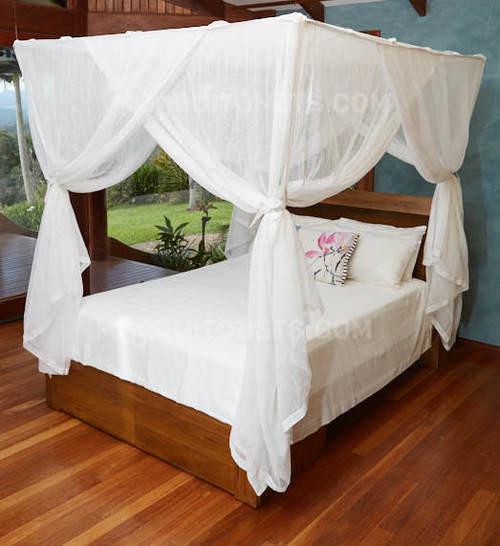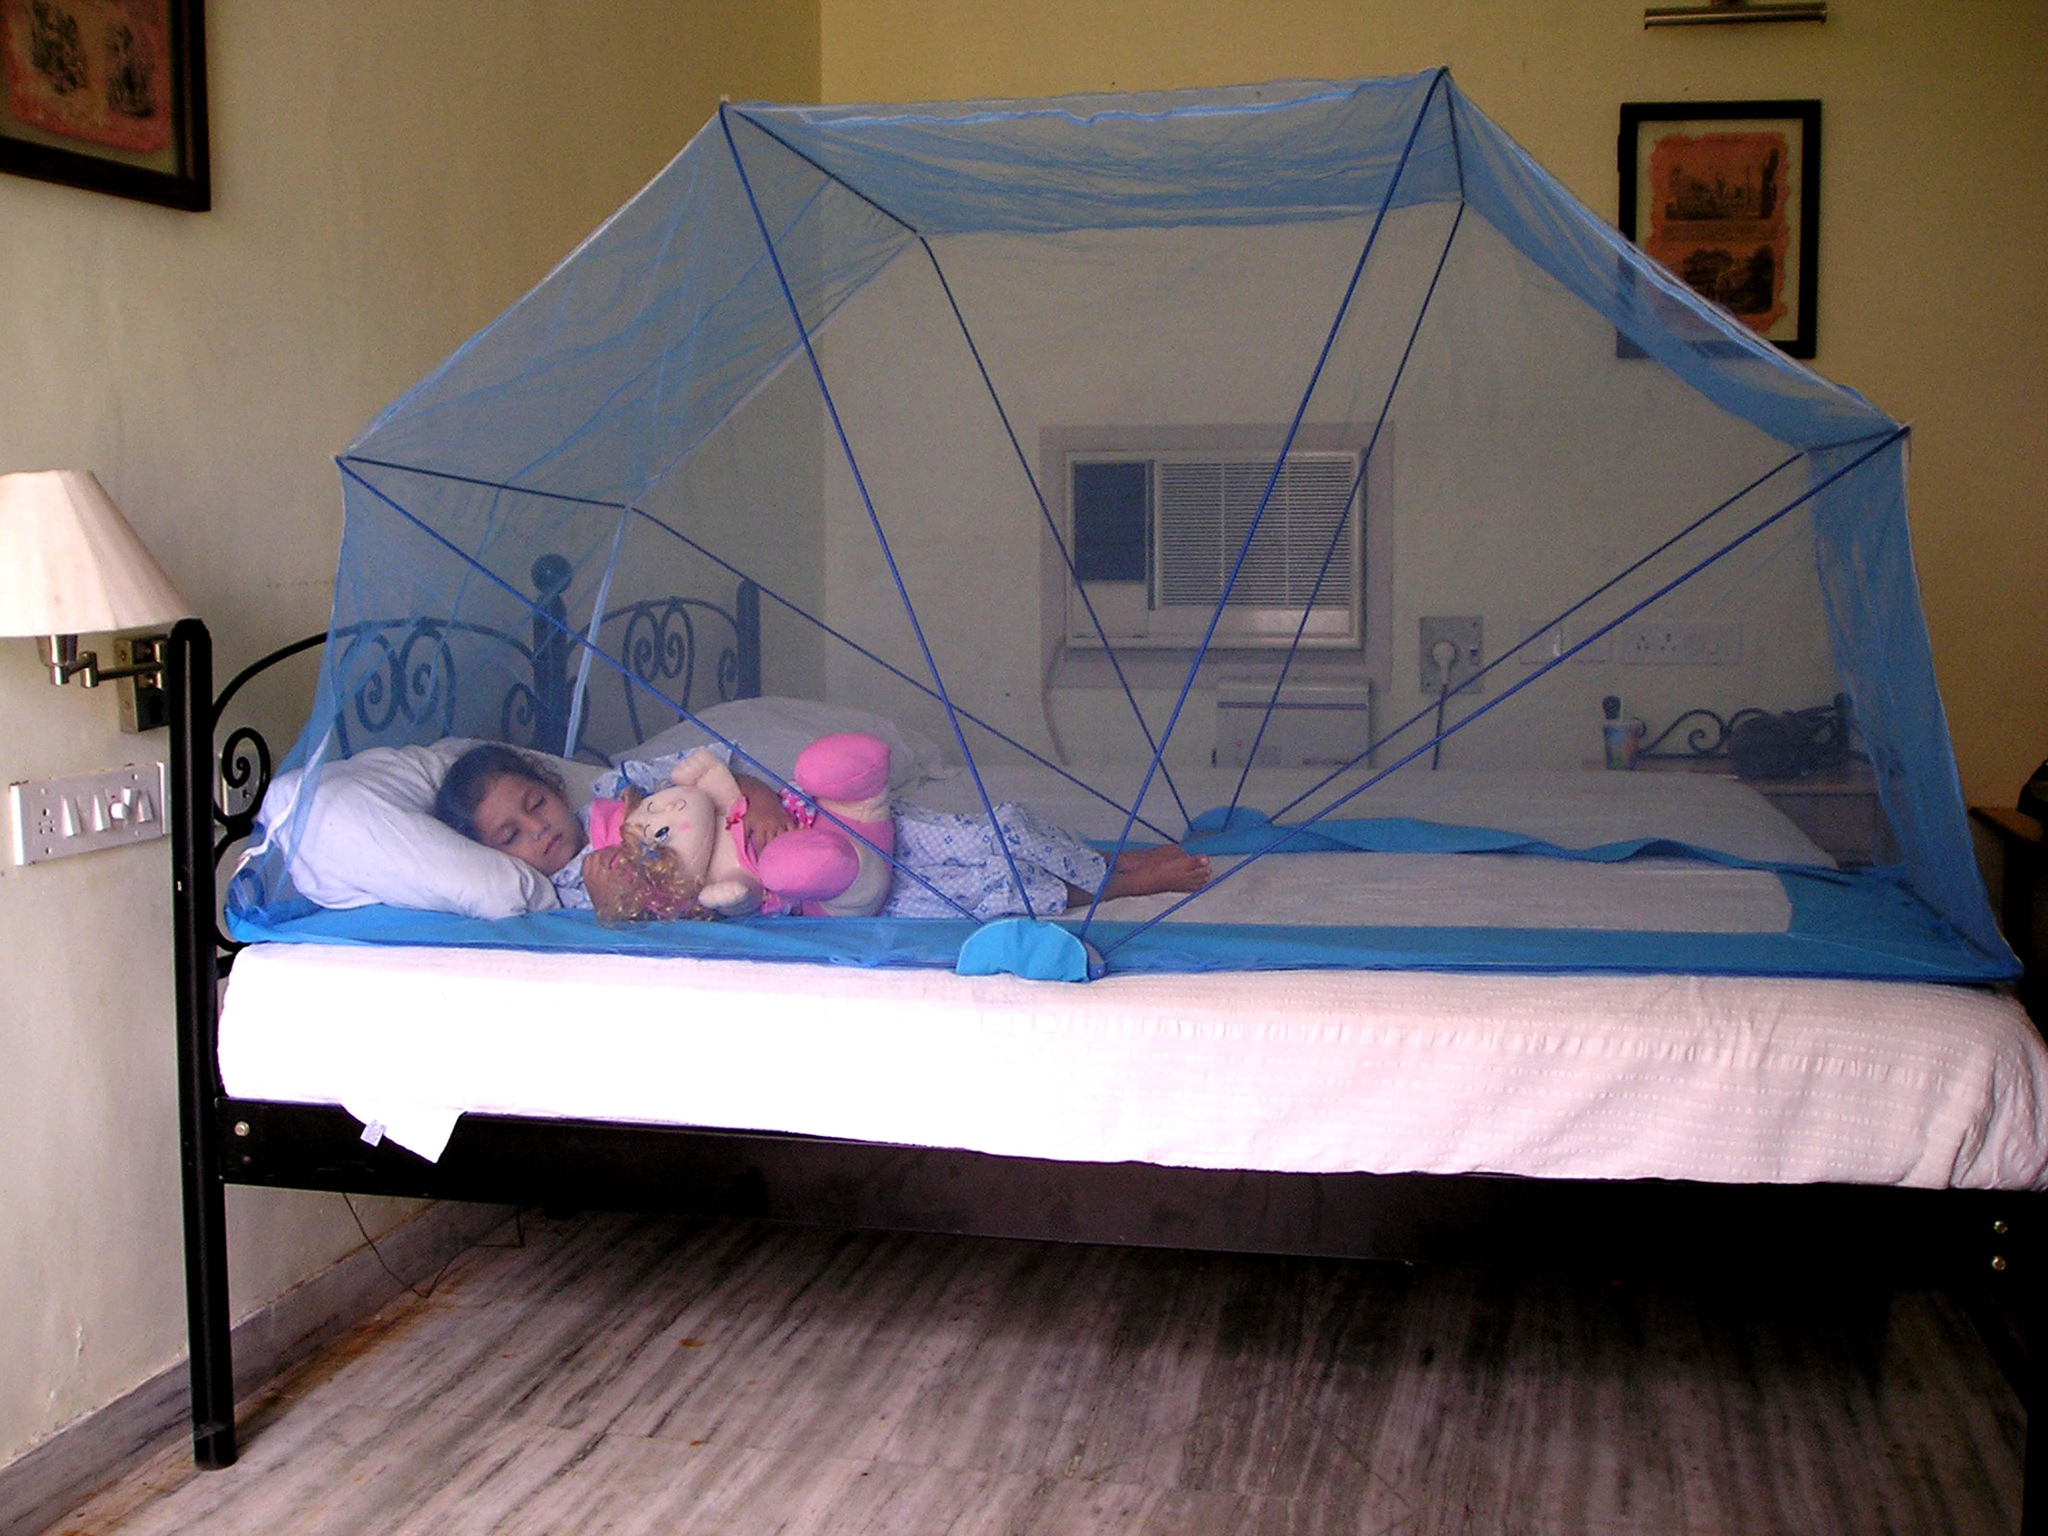The first image is the image on the left, the second image is the image on the right. Analyze the images presented: Is the assertion "The left image shows a rounded dome bed enclosure." valid? Answer yes or no. No. 